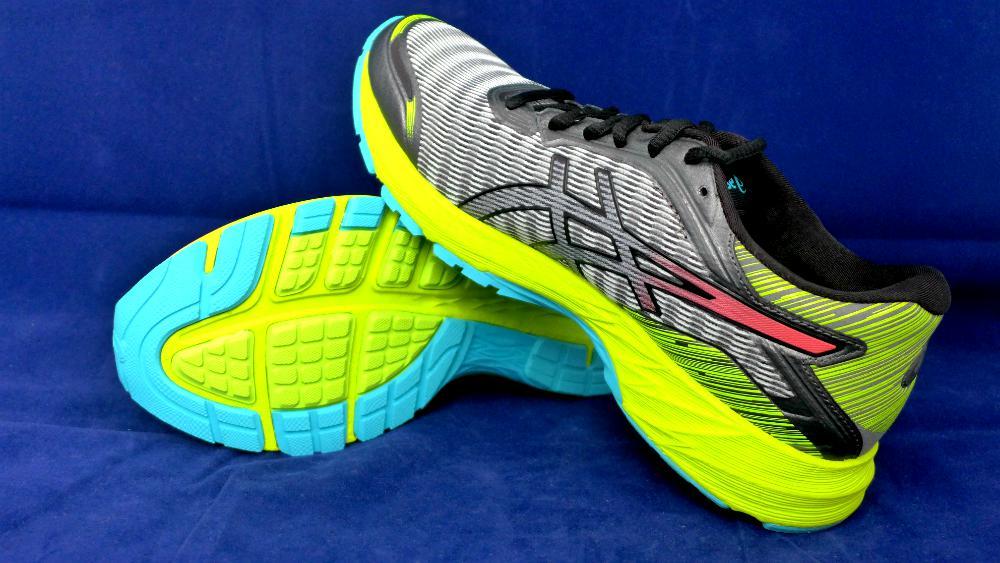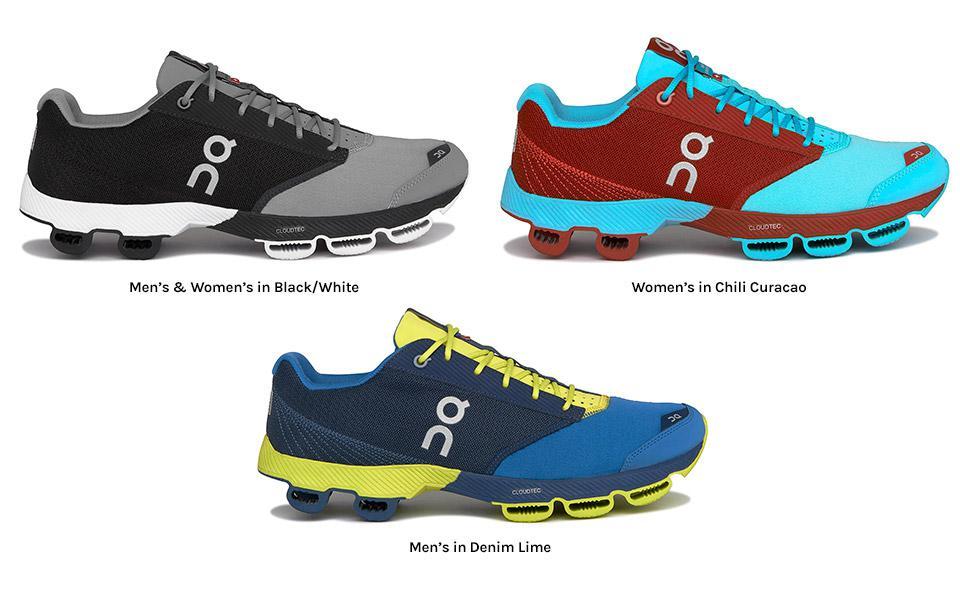The first image is the image on the left, the second image is the image on the right. Given the left and right images, does the statement "The left image shows a pair of sneakers with one of the sneakers resting partially atop the other" hold true? Answer yes or no. Yes. The first image is the image on the left, the second image is the image on the right. Examine the images to the left and right. Is the description "There is exactly three tennis shoes." accurate? Answer yes or no. No. 